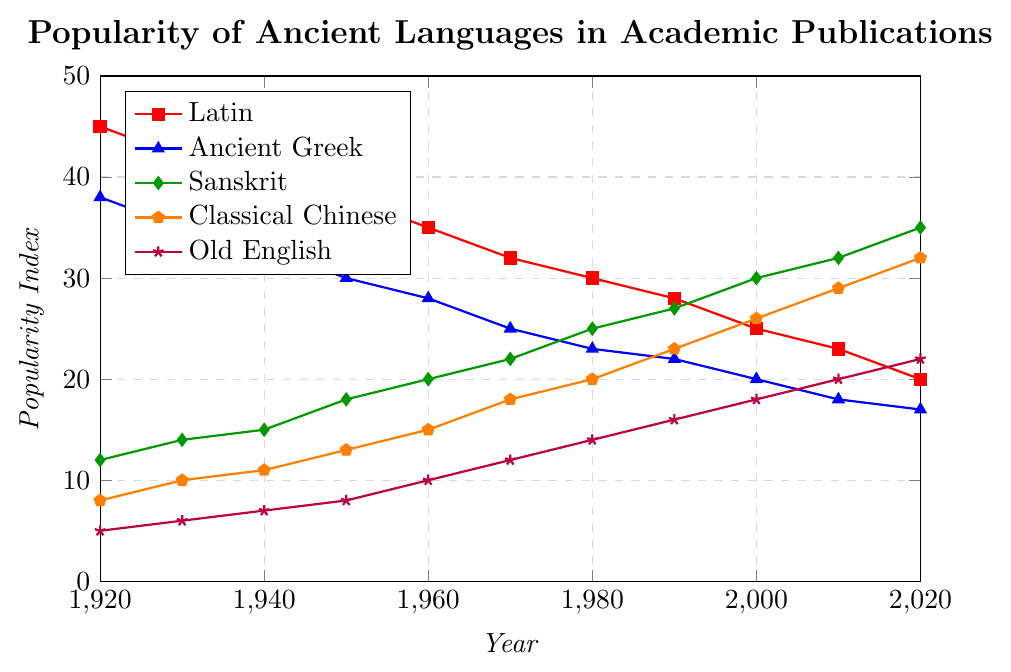What's the overall trend of Latin's popularity from 1920 to 2020? The figure shows data points for Latin's popularity from 1920 to 2020. Observing the line, it starts at 45 in 1920 and steadily declines to 20 by 2020, indicating a consistent downward trend over the century.
Answer: A steady decline Which ancient language shows the most significant increase in popularity from 1920 to 2020? To determine the most significant increase, look at the initial and final data points for each language. Sanskrit starts at 12 in 1920 and reaches 35 in 2020, an increase of 23 points, which is the largest when compared to other languages.
Answer: Sanskrit In which year did Classical Chinese surpass Latin in popularity? By analyzing the intersection points on the chart, Classical Chinese surpasses Latin around the year 2000. In this year, Classical Chinese's index is 26, while Latin's is 25.
Answer: 2000 How does the popularity trend of Old English compare with that of Ancient Greek over the century? The chart shows that both Old English and Ancient Greek have an upward and downward trend, respectively. Old English starts at 5 in 1920 and reaches 22 in 2020, whereas Ancient Greek starts at 38 and decreases to 17 in the same period.
Answer: Old English increases, Ancient Greek decreases What is the sum of the popularity indices of Sanskrit and Classical Chinese in 2020? The popularity indices of Sanskrit and Classical Chinese in 2020 are 35 and 32, respectively. Their sum is 35 + 32 = 67.
Answer: 67 Which language had a lower popularity index than all others in the 1920s, and what was its index? Observing the initial values for each language in 1920, Old English has the lowest index at 5.
Answer: Old English, 5 What is the average popularity index of Latin from 1920 to 2020? Summing Latin's indices from 1920 to 2020 is 45 + 42 + 40 + 38 + 35 + 32 + 30 + 28 + 25 + 23 + 20 = 358. There are 11 data points, so the average is 358 / 11 ≈ 32.55.
Answer: 32.55 Compare the popularity of Sanskrit and Old English in the year 1980. Which one was more popular and by how much? In 1980, the popularity index for Sanskrit is 25, while Old English is 14. Sanskrit is more popular by 25 - 14 = 11 points.
Answer: Sanskrit by 11 points How many languages have their maximum popularity index figure in 2020? Observing each line on the chart, both Sanskrit and Classical Chinese reach their maximum values in 2020. No other languages peak in 2020.
Answer: 2 